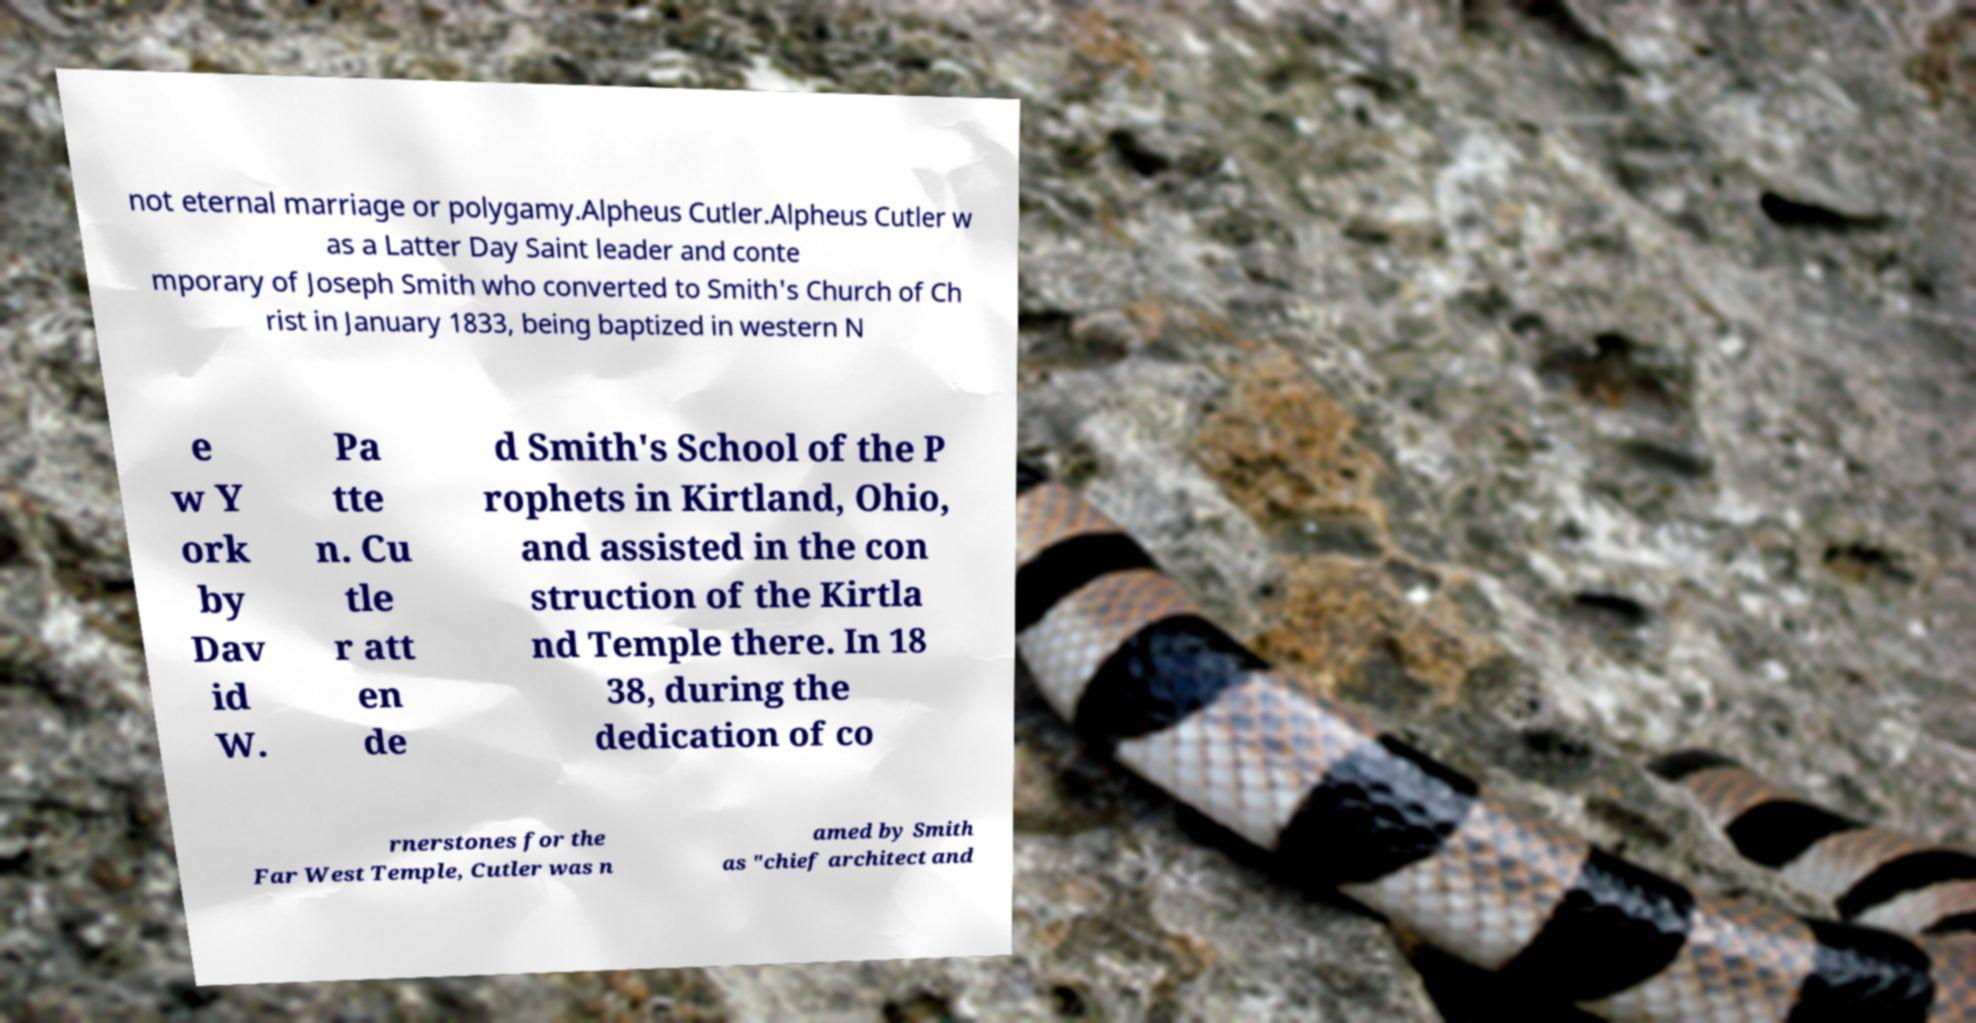I need the written content from this picture converted into text. Can you do that? not eternal marriage or polygamy.Alpheus Cutler.Alpheus Cutler w as a Latter Day Saint leader and conte mporary of Joseph Smith who converted to Smith's Church of Ch rist in January 1833, being baptized in western N e w Y ork by Dav id W. Pa tte n. Cu tle r att en de d Smith's School of the P rophets in Kirtland, Ohio, and assisted in the con struction of the Kirtla nd Temple there. In 18 38, during the dedication of co rnerstones for the Far West Temple, Cutler was n amed by Smith as "chief architect and 